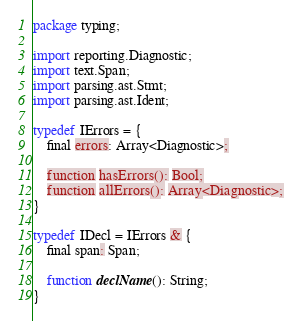Convert code to text. <code><loc_0><loc_0><loc_500><loc_500><_Haxe_>package typing;

import reporting.Diagnostic;
import text.Span;
import parsing.ast.Stmt;
import parsing.ast.Ident;

typedef IErrors = {
	final errors: Array<Diagnostic>;

	function hasErrors(): Bool;
	function allErrors(): Array<Diagnostic>;
}

typedef IDecl = IErrors & {
	final span: Span;
	
	function declName(): String;
}
</code> 